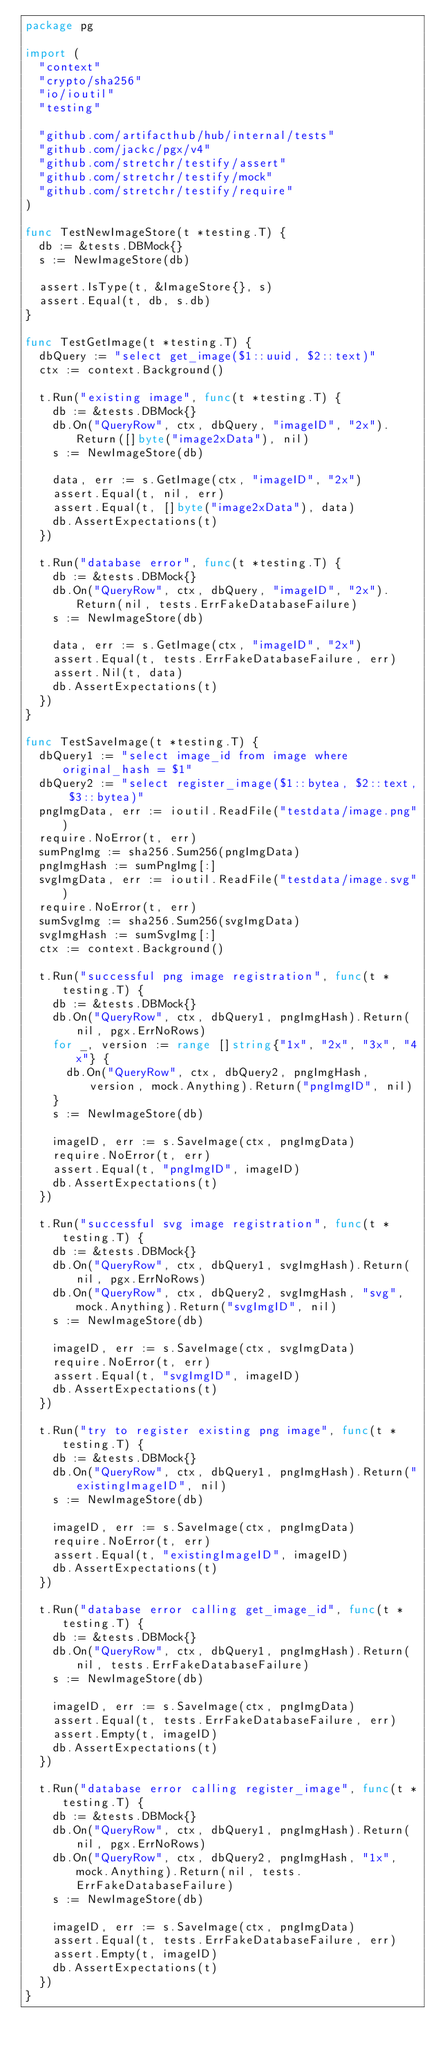<code> <loc_0><loc_0><loc_500><loc_500><_Go_>package pg

import (
	"context"
	"crypto/sha256"
	"io/ioutil"
	"testing"

	"github.com/artifacthub/hub/internal/tests"
	"github.com/jackc/pgx/v4"
	"github.com/stretchr/testify/assert"
	"github.com/stretchr/testify/mock"
	"github.com/stretchr/testify/require"
)

func TestNewImageStore(t *testing.T) {
	db := &tests.DBMock{}
	s := NewImageStore(db)

	assert.IsType(t, &ImageStore{}, s)
	assert.Equal(t, db, s.db)
}

func TestGetImage(t *testing.T) {
	dbQuery := "select get_image($1::uuid, $2::text)"
	ctx := context.Background()

	t.Run("existing image", func(t *testing.T) {
		db := &tests.DBMock{}
		db.On("QueryRow", ctx, dbQuery, "imageID", "2x").Return([]byte("image2xData"), nil)
		s := NewImageStore(db)

		data, err := s.GetImage(ctx, "imageID", "2x")
		assert.Equal(t, nil, err)
		assert.Equal(t, []byte("image2xData"), data)
		db.AssertExpectations(t)
	})

	t.Run("database error", func(t *testing.T) {
		db := &tests.DBMock{}
		db.On("QueryRow", ctx, dbQuery, "imageID", "2x").Return(nil, tests.ErrFakeDatabaseFailure)
		s := NewImageStore(db)

		data, err := s.GetImage(ctx, "imageID", "2x")
		assert.Equal(t, tests.ErrFakeDatabaseFailure, err)
		assert.Nil(t, data)
		db.AssertExpectations(t)
	})
}

func TestSaveImage(t *testing.T) {
	dbQuery1 := "select image_id from image where original_hash = $1"
	dbQuery2 := "select register_image($1::bytea, $2::text, $3::bytea)"
	pngImgData, err := ioutil.ReadFile("testdata/image.png")
	require.NoError(t, err)
	sumPngImg := sha256.Sum256(pngImgData)
	pngImgHash := sumPngImg[:]
	svgImgData, err := ioutil.ReadFile("testdata/image.svg")
	require.NoError(t, err)
	sumSvgImg := sha256.Sum256(svgImgData)
	svgImgHash := sumSvgImg[:]
	ctx := context.Background()

	t.Run("successful png image registration", func(t *testing.T) {
		db := &tests.DBMock{}
		db.On("QueryRow", ctx, dbQuery1, pngImgHash).Return(nil, pgx.ErrNoRows)
		for _, version := range []string{"1x", "2x", "3x", "4x"} {
			db.On("QueryRow", ctx, dbQuery2, pngImgHash, version, mock.Anything).Return("pngImgID", nil)
		}
		s := NewImageStore(db)

		imageID, err := s.SaveImage(ctx, pngImgData)
		require.NoError(t, err)
		assert.Equal(t, "pngImgID", imageID)
		db.AssertExpectations(t)
	})

	t.Run("successful svg image registration", func(t *testing.T) {
		db := &tests.DBMock{}
		db.On("QueryRow", ctx, dbQuery1, svgImgHash).Return(nil, pgx.ErrNoRows)
		db.On("QueryRow", ctx, dbQuery2, svgImgHash, "svg", mock.Anything).Return("svgImgID", nil)
		s := NewImageStore(db)

		imageID, err := s.SaveImage(ctx, svgImgData)
		require.NoError(t, err)
		assert.Equal(t, "svgImgID", imageID)
		db.AssertExpectations(t)
	})

	t.Run("try to register existing png image", func(t *testing.T) {
		db := &tests.DBMock{}
		db.On("QueryRow", ctx, dbQuery1, pngImgHash).Return("existingImageID", nil)
		s := NewImageStore(db)

		imageID, err := s.SaveImage(ctx, pngImgData)
		require.NoError(t, err)
		assert.Equal(t, "existingImageID", imageID)
		db.AssertExpectations(t)
	})

	t.Run("database error calling get_image_id", func(t *testing.T) {
		db := &tests.DBMock{}
		db.On("QueryRow", ctx, dbQuery1, pngImgHash).Return(nil, tests.ErrFakeDatabaseFailure)
		s := NewImageStore(db)

		imageID, err := s.SaveImage(ctx, pngImgData)
		assert.Equal(t, tests.ErrFakeDatabaseFailure, err)
		assert.Empty(t, imageID)
		db.AssertExpectations(t)
	})

	t.Run("database error calling register_image", func(t *testing.T) {
		db := &tests.DBMock{}
		db.On("QueryRow", ctx, dbQuery1, pngImgHash).Return(nil, pgx.ErrNoRows)
		db.On("QueryRow", ctx, dbQuery2, pngImgHash, "1x", mock.Anything).Return(nil, tests.ErrFakeDatabaseFailure)
		s := NewImageStore(db)

		imageID, err := s.SaveImage(ctx, pngImgData)
		assert.Equal(t, tests.ErrFakeDatabaseFailure, err)
		assert.Empty(t, imageID)
		db.AssertExpectations(t)
	})
}
</code> 